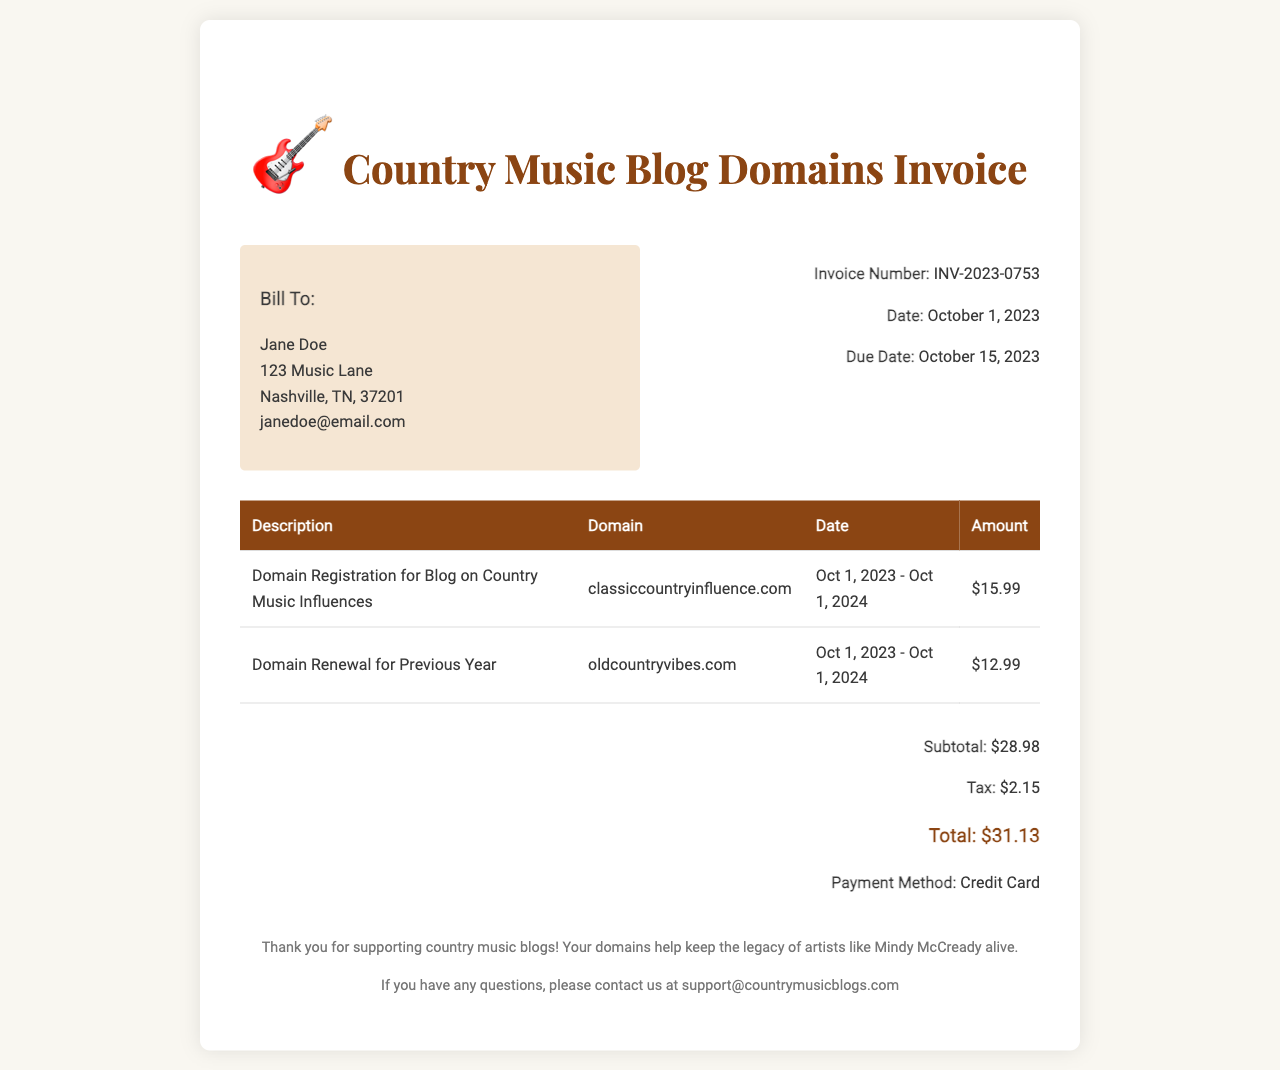What is the invoice number? The invoice number is listed under the invoice details section, indicating a unique identifier for this transaction.
Answer: INV-2023-0753 What is the due date? The due date is specified in the invoice details and indicates the date by which payment must be completed.
Answer: October 15, 2023 What domains are included in this invoice? The invoice lists two domains that were registered or renewed, which is essential for the blog's online presence.
Answer: classiccountryinfluence.com, oldcountryvibes.com What is the total amount due? The total amount is calculated by summing the subtotal and tax, indicating the final payment needed.
Answer: $31.13 What is the tax amount? The tax amount is provided in the total section of the invoice, representing the additional charge over the subtotal.
Answer: $2.15 How long is the registration period for classiccountryinfluence.com? The registration period is specified in the invoice, indicating how long the domain will be registered for the blog.
Answer: Oct 1, 2023 - Oct 1, 2024 Who is the bill recipient? The bill recipient's details are outlined in the invoice header, important for confirming who the invoice is addressed to.
Answer: Jane Doe What method of payment was used? The method of payment is mentioned in the total section, providing information on how the transaction was completed.
Answer: Credit Card 